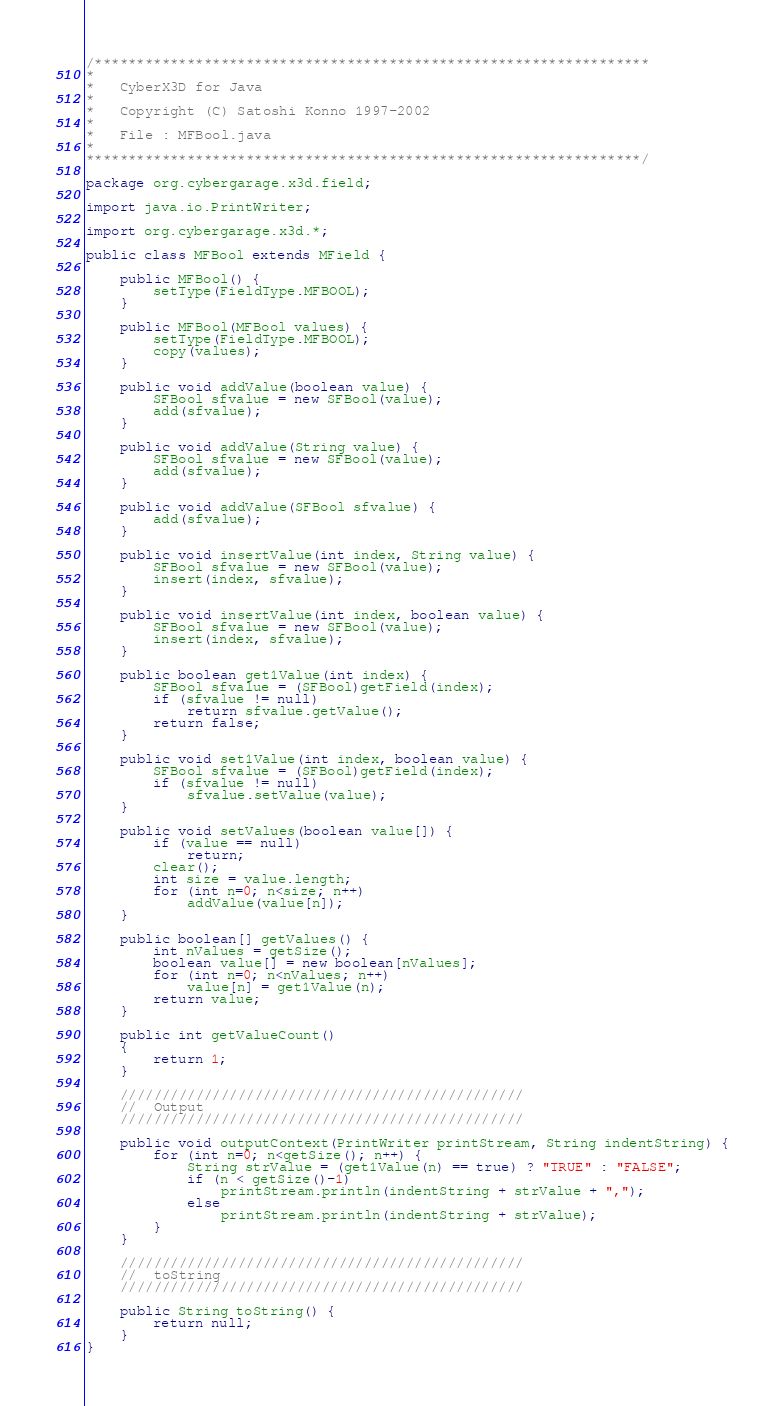<code> <loc_0><loc_0><loc_500><loc_500><_Java_>/******************************************************************
*
*	CyberX3D for Java
*
*	Copyright (C) Satoshi Konno 1997-2002
*
*	File : MFBool.java
*
******************************************************************/

package org.cybergarage.x3d.field;

import java.io.PrintWriter;

import org.cybergarage.x3d.*;

public class MFBool extends MField {

	public MFBool() {
		setType(FieldType.MFBOOL);
	}

	public MFBool(MFBool values) {
		setType(FieldType.MFBOOL);
		copy(values);
	}

	public void addValue(boolean value) {
		SFBool sfvalue = new SFBool(value);
		add(sfvalue);
	}

	public void addValue(String value) {
		SFBool sfvalue = new SFBool(value);
		add(sfvalue);
	}
	
	public void addValue(SFBool sfvalue) {
		add(sfvalue);
	}

	public void insertValue(int index, String value) {
		SFBool sfvalue = new SFBool(value);
		insert(index, sfvalue);
	}
	
	public void insertValue(int index, boolean value) {
		SFBool sfvalue = new SFBool(value);
		insert(index, sfvalue);
	}

	public boolean get1Value(int index) {
		SFBool sfvalue = (SFBool)getField(index);
		if (sfvalue != null)
			return sfvalue.getValue();
		return false;		
	}

	public void set1Value(int index, boolean value) {
		SFBool sfvalue = (SFBool)getField(index);
		if (sfvalue != null)
			sfvalue.setValue(value);
	}

	public void setValues(boolean value[]) {
		if (value == null)
			return;
		clear();
		int size = value.length;
		for (int n=0; n<size; n++)
			addValue(value[n]);
	}

	public boolean[] getValues() {
		int nValues = getSize();
		boolean value[] = new boolean[nValues];
		for (int n=0; n<nValues; n++) 
			value[n] = get1Value(n);
		return value;
	}

	public int getValueCount()
	{
		return 1;
	}

	////////////////////////////////////////////////
	//	Output
	////////////////////////////////////////////////

	public void outputContext(PrintWriter printStream, String indentString) {
		for (int n=0; n<getSize(); n++) {
			String strValue = (get1Value(n) == true) ? "TRUE" : "FALSE"; 
			if (n < getSize()-1)
				printStream.println(indentString + strValue + ",");
			else	
				printStream.println(indentString + strValue);
		}
	}

	////////////////////////////////////////////////
	//	toString
	////////////////////////////////////////////////

	public String toString() {
		return null;
	}
}</code> 